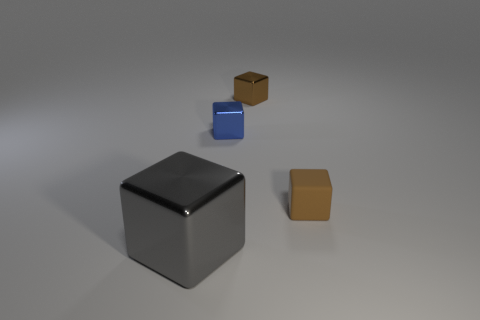Add 1 large gray metallic blocks. How many large gray metallic blocks exist? 2 Add 2 big shiny cubes. How many objects exist? 6 Subtract all blue blocks. How many blocks are left? 3 Subtract all tiny blocks. How many blocks are left? 1 Subtract 0 brown spheres. How many objects are left? 4 Subtract 3 cubes. How many cubes are left? 1 Subtract all gray cubes. Subtract all yellow cylinders. How many cubes are left? 3 Subtract all brown balls. How many green blocks are left? 0 Subtract all tiny cyan rubber spheres. Subtract all tiny brown metallic things. How many objects are left? 3 Add 1 small cubes. How many small cubes are left? 4 